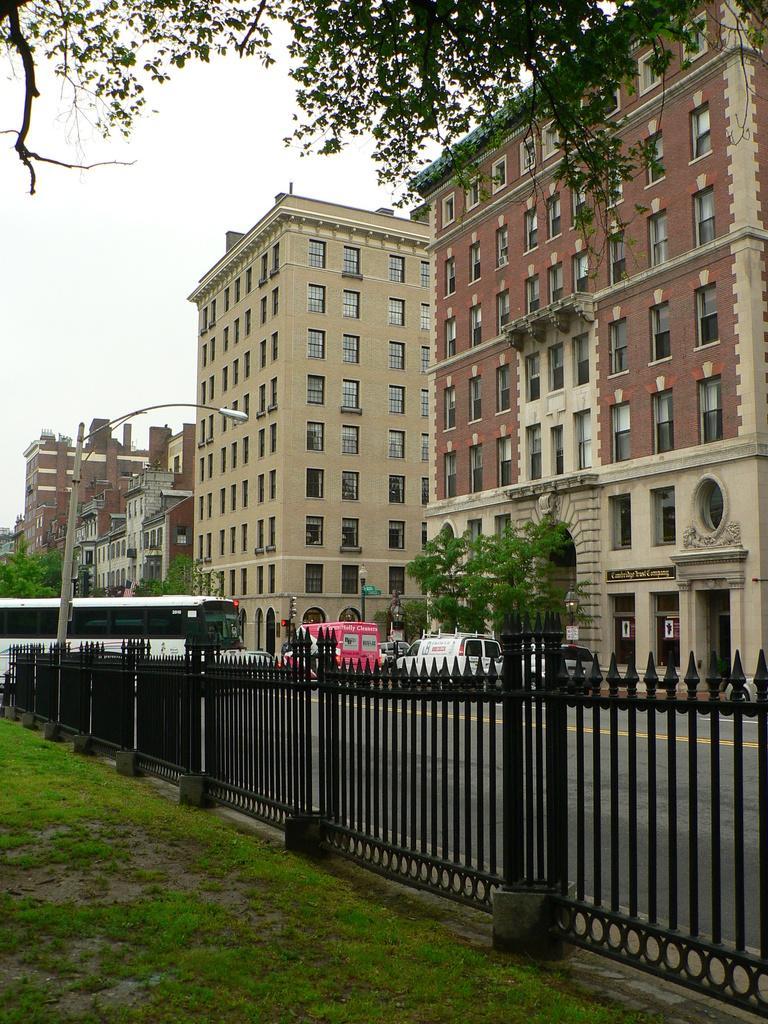Could you give a brief overview of what you see in this image? In this image I can see at the bottom it looks like a metal fence. On the left side a vehicle is moving on the road, at the back side there are trees, on the right side there are buildings. At the top it is the sky. 